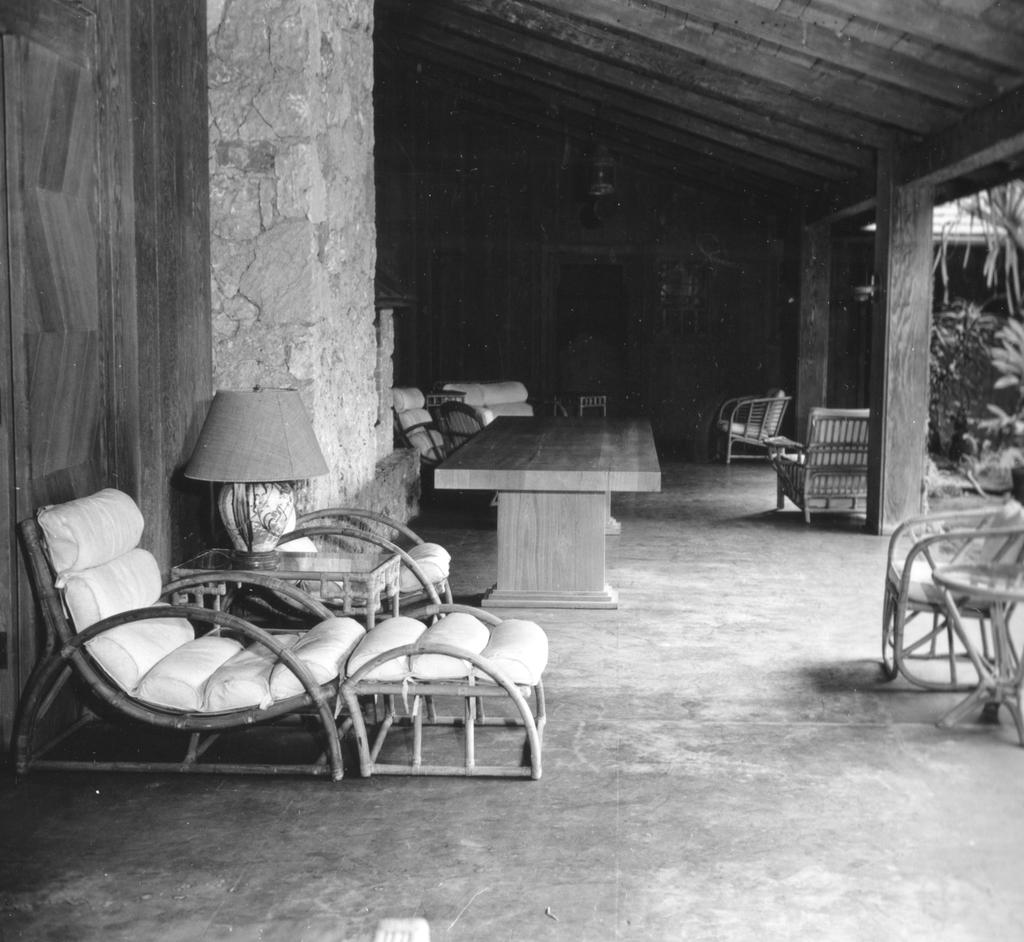What type of lighting fixture is present in the image? There is a table lamp in the image. What type of furniture is visible in the image? There are chairs and tables in the image. What type of structure is present in the image? There is a shed in the image. What architectural feature is present in the image? There are pillars in the image. What type of vegetation is on the right side of the image? There are plants on the right side of the image. Can you tell me what picture the boy is holding in the image? There is no boy or picture present in the image. What type of camera is being used to take the picture in the image? There is no camera or picture being taken in the image. 